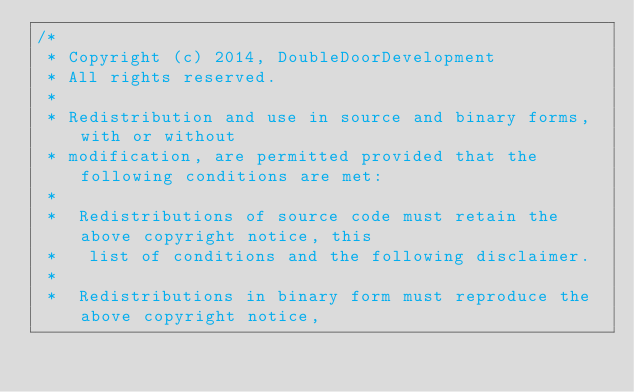<code> <loc_0><loc_0><loc_500><loc_500><_Java_>/*
 * Copyright (c) 2014, DoubleDoorDevelopment
 * All rights reserved.
 *
 * Redistribution and use in source and binary forms, with or without
 * modification, are permitted provided that the following conditions are met:
 *
 *  Redistributions of source code must retain the above copyright notice, this
 *   list of conditions and the following disclaimer.
 *
 *  Redistributions in binary form must reproduce the above copyright notice,</code> 